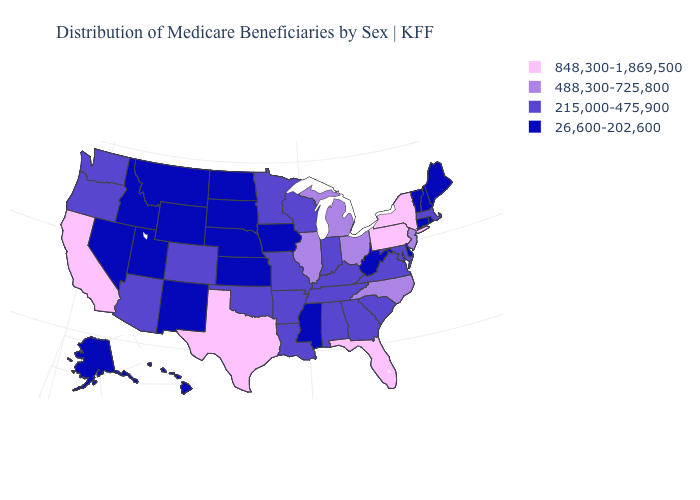Name the states that have a value in the range 215,000-475,900?
Keep it brief. Alabama, Arizona, Arkansas, Colorado, Georgia, Indiana, Kentucky, Louisiana, Maryland, Massachusetts, Minnesota, Missouri, Oklahoma, Oregon, South Carolina, Tennessee, Virginia, Washington, Wisconsin. What is the value of Connecticut?
Keep it brief. 26,600-202,600. Does Delaware have the lowest value in the USA?
Give a very brief answer. Yes. Name the states that have a value in the range 488,300-725,800?
Quick response, please. Illinois, Michigan, New Jersey, North Carolina, Ohio. What is the value of Indiana?
Quick response, please. 215,000-475,900. Name the states that have a value in the range 26,600-202,600?
Be succinct. Alaska, Connecticut, Delaware, Hawaii, Idaho, Iowa, Kansas, Maine, Mississippi, Montana, Nebraska, Nevada, New Hampshire, New Mexico, North Dakota, Rhode Island, South Dakota, Utah, Vermont, West Virginia, Wyoming. Among the states that border Missouri , which have the highest value?
Be succinct. Illinois. What is the value of Alaska?
Give a very brief answer. 26,600-202,600. Among the states that border Nevada , which have the lowest value?
Write a very short answer. Idaho, Utah. Among the states that border Tennessee , which have the lowest value?
Write a very short answer. Mississippi. Does Minnesota have a higher value than Nebraska?
Answer briefly. Yes. Among the states that border New Jersey , which have the lowest value?
Short answer required. Delaware. Does Alaska have the highest value in the USA?
Answer briefly. No. Name the states that have a value in the range 26,600-202,600?
Answer briefly. Alaska, Connecticut, Delaware, Hawaii, Idaho, Iowa, Kansas, Maine, Mississippi, Montana, Nebraska, Nevada, New Hampshire, New Mexico, North Dakota, Rhode Island, South Dakota, Utah, Vermont, West Virginia, Wyoming. Which states have the lowest value in the MidWest?
Answer briefly. Iowa, Kansas, Nebraska, North Dakota, South Dakota. 